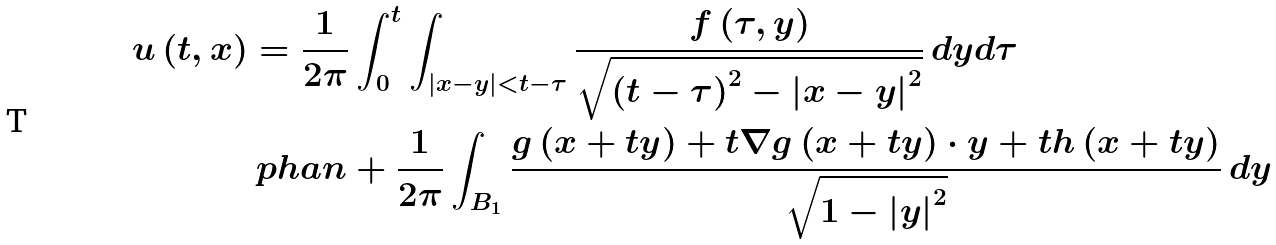<formula> <loc_0><loc_0><loc_500><loc_500>u \left ( t , x \right ) & = \frac { 1 } { 2 \pi } \int _ { 0 } ^ { t } { \int _ { \left | x - y \right | < t - \tau } { \frac { f \left ( \tau , y \right ) } { \sqrt { \left ( t - \tau \right ) ^ { 2 } - \left | x - y \right | ^ { 2 } } } \, d y d \tau } } \\ & \ p h a n + \frac { 1 } { 2 \pi } \int _ { B _ { 1 } } { \frac { g \left ( x + t y \right ) + t \nabla g \left ( x + t y \right ) \cdot y + t h \left ( x + t y \right ) } { \sqrt { 1 - \left | y \right | ^ { 2 } } } \, d y }</formula> 